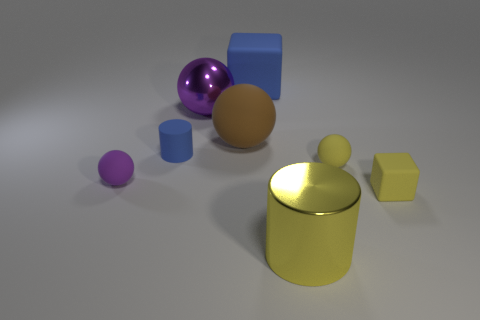Subtract 1 cylinders. How many cylinders are left? 1 Subtract all yellow spheres. How many spheres are left? 3 Subtract 0 cyan cylinders. How many objects are left? 8 Subtract all cubes. How many objects are left? 6 Subtract all yellow cylinders. Subtract all brown blocks. How many cylinders are left? 1 Subtract all cyan cubes. How many brown spheres are left? 1 Subtract all tiny green rubber objects. Subtract all big blue rubber blocks. How many objects are left? 7 Add 1 large blue rubber blocks. How many large blue rubber blocks are left? 2 Add 4 blue things. How many blue things exist? 6 Add 2 brown metal cylinders. How many objects exist? 10 